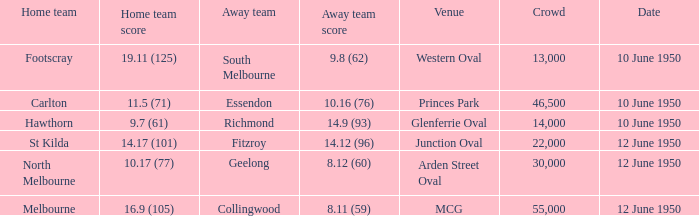Who was the away team when the VFL played at MCG? Collingwood. 